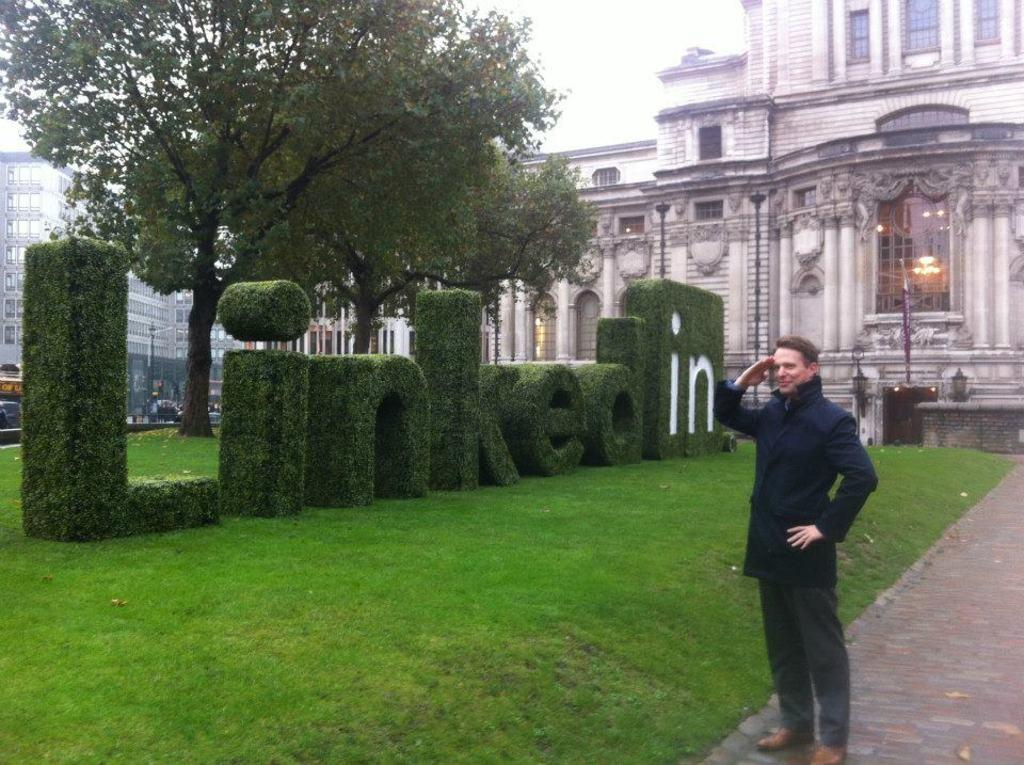What is the main subject of the image? There is a man standing in the middle of the image. What can be seen behind the man? There is grass, trees, and buildings behind the man. What is visible at the top of the image? The sky is visible at the top of the image. How many dogs are pulling the man in the image? There are no dogs present in the image, so they cannot be pulling the man. 